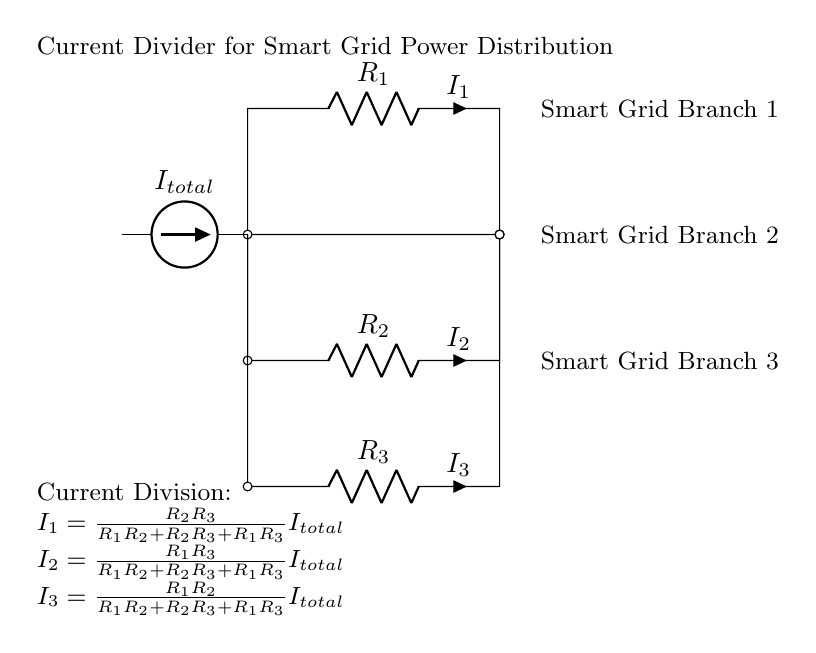What is the total current in the circuit? The total current, denoted as I total, is represented by the current source on the left side of the circuit. It feeds into the node where all resistors connect.
Answer: I total What resistors are present in the circuit? The circuit contains three resistors, labeled R1, R2, and R3. They are connected in parallel to the current source at the top node.
Answer: R1, R2, R3 How many branches are there in this circuit? The circuit has three branches corresponding to different resistors (R1, R2, R3). Each resistor represents one branch where the current can flow.
Answer: Three What is the current through R2? According to the formula provided, the current through R2, denoted as I2, can be calculated from the equation given for a current divider, using values of the resistors and I total.
Answer: I2 = (R1 * R3 / (R1 * R2 + R2 * R3 + R1 * R3)) * I total What does the circuit diagram represent in terms of application? The current divider circuit represents a system for power distribution in smart grids, where the current is split among different branches, reflecting the nature of smart grid technology.
Answer: Power distribution in smart grids What is the role of the current divider in this circuit? The current divider’s role is to distribute the total current from the source into the individual branch currents based on the values of the resistors. This helps analyze how much current will flow through each branch, crucial for ensuring optimal operation of the circuit.
Answer: Distributing total current 